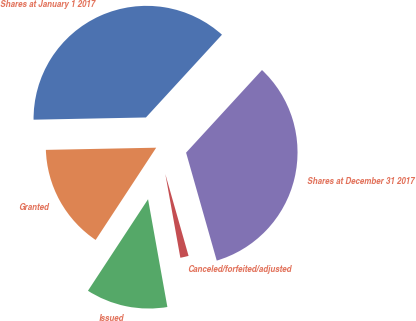Convert chart to OTSL. <chart><loc_0><loc_0><loc_500><loc_500><pie_chart><fcel>Shares at January 1 2017<fcel>Granted<fcel>Issued<fcel>Canceled/forfeited/adjusted<fcel>Shares at December 31 2017<nl><fcel>37.14%<fcel>15.44%<fcel>12.07%<fcel>1.58%<fcel>33.77%<nl></chart> 